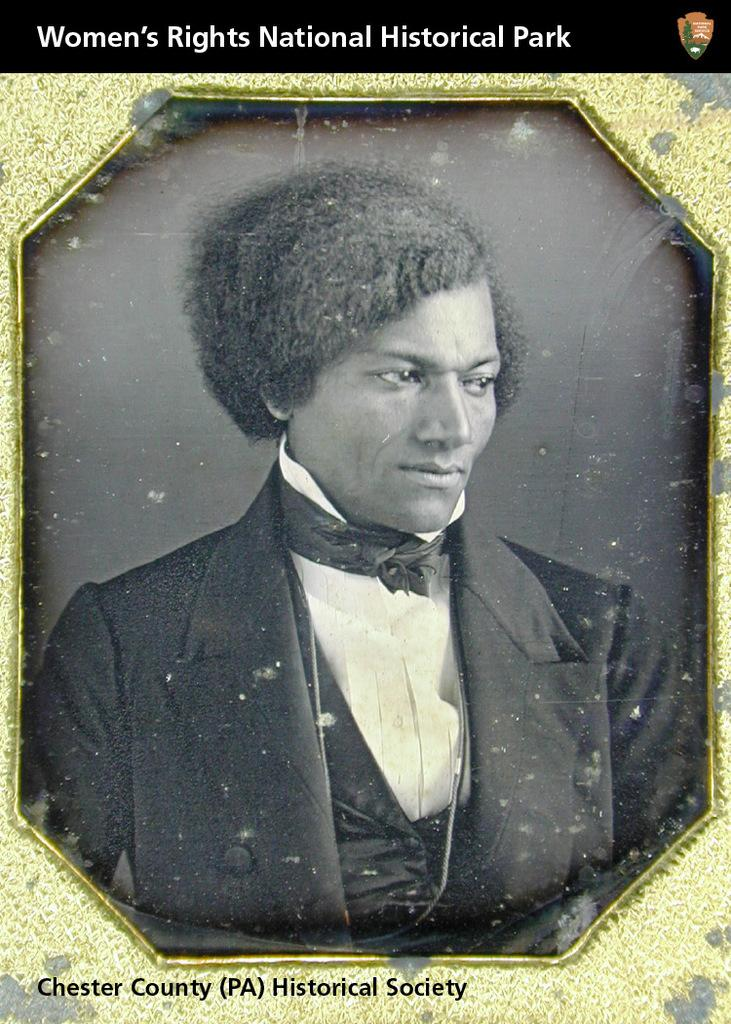<image>
Give a short and clear explanation of the subsequent image. A picure bearing the words Women's RIghts National Historical Park portrays a very old image of well groomed black man. 